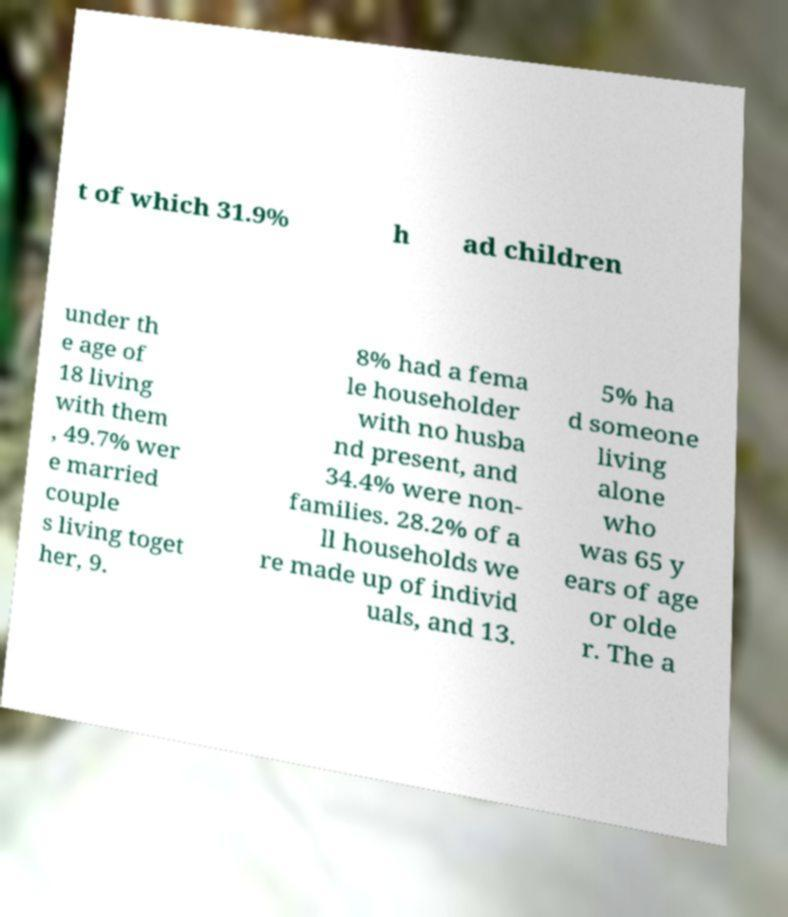There's text embedded in this image that I need extracted. Can you transcribe it verbatim? t of which 31.9% h ad children under th e age of 18 living with them , 49.7% wer e married couple s living toget her, 9. 8% had a fema le householder with no husba nd present, and 34.4% were non- families. 28.2% of a ll households we re made up of individ uals, and 13. 5% ha d someone living alone who was 65 y ears of age or olde r. The a 